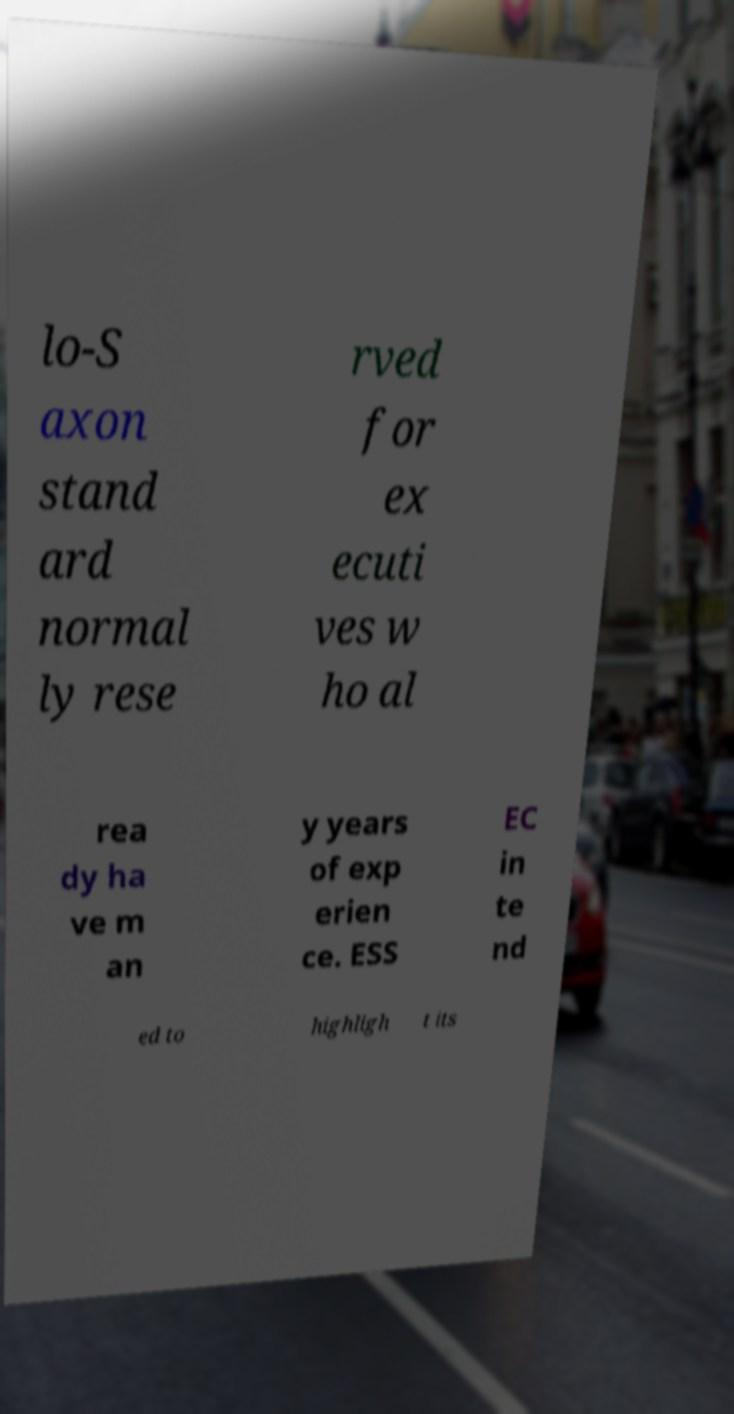Can you read and provide the text displayed in the image? This photo seems to have some interesting text. Can you extract and type it out for me? The image appears to display a partially obscured text, possibly from a brochure or an informational document. It seems to discuss a topic related to a 'standard normally reserved for executives who already have many years of experience.' The text also appears to mention 'ESSEC intended to highlight its', although the full context of this statement is cut off. Due to the blurring and angle of the photo, full extraction of the text isn't possible, but these are the discernible fragments. 